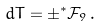<formula> <loc_0><loc_0><loc_500><loc_500>d T = \pm ^ { * } \mathcal { F } _ { 9 } \, .</formula> 